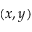<formula> <loc_0><loc_0><loc_500><loc_500>( x , y )</formula> 